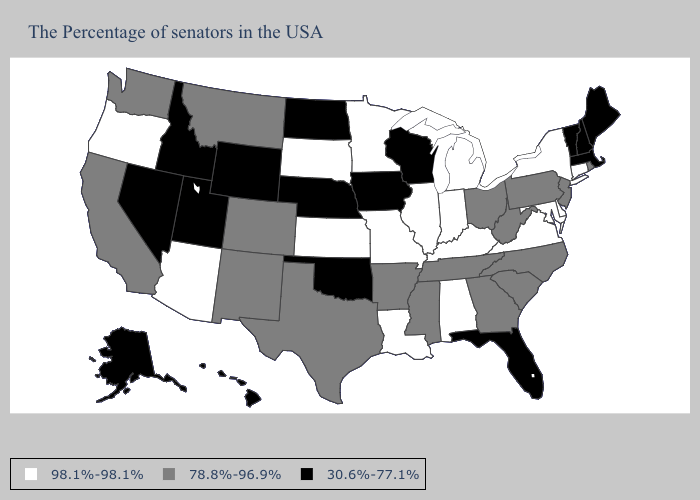Which states hav the highest value in the West?
Be succinct. Arizona, Oregon. Does Pennsylvania have the highest value in the USA?
Answer briefly. No. What is the value of Indiana?
Give a very brief answer. 98.1%-98.1%. What is the value of Arkansas?
Concise answer only. 78.8%-96.9%. Among the states that border Michigan , does Wisconsin have the lowest value?
Give a very brief answer. Yes. What is the highest value in states that border Idaho?
Short answer required. 98.1%-98.1%. Name the states that have a value in the range 78.8%-96.9%?
Give a very brief answer. Rhode Island, New Jersey, Pennsylvania, North Carolina, South Carolina, West Virginia, Ohio, Georgia, Tennessee, Mississippi, Arkansas, Texas, Colorado, New Mexico, Montana, California, Washington. What is the value of Alabama?
Quick response, please. 98.1%-98.1%. Name the states that have a value in the range 30.6%-77.1%?
Short answer required. Maine, Massachusetts, New Hampshire, Vermont, Florida, Wisconsin, Iowa, Nebraska, Oklahoma, North Dakota, Wyoming, Utah, Idaho, Nevada, Alaska, Hawaii. What is the value of Hawaii?
Keep it brief. 30.6%-77.1%. Is the legend a continuous bar?
Short answer required. No. Which states have the lowest value in the Northeast?
Concise answer only. Maine, Massachusetts, New Hampshire, Vermont. Which states hav the highest value in the West?
Write a very short answer. Arizona, Oregon. What is the value of West Virginia?
Concise answer only. 78.8%-96.9%. Does Pennsylvania have the lowest value in the Northeast?
Give a very brief answer. No. 